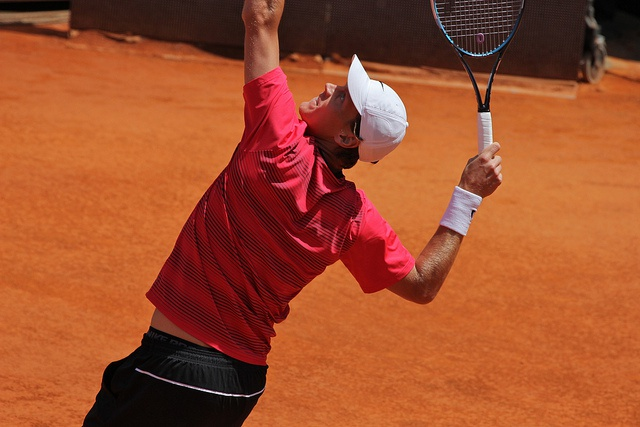Describe the objects in this image and their specific colors. I can see people in maroon, black, and red tones and tennis racket in maroon, black, gray, and brown tones in this image. 